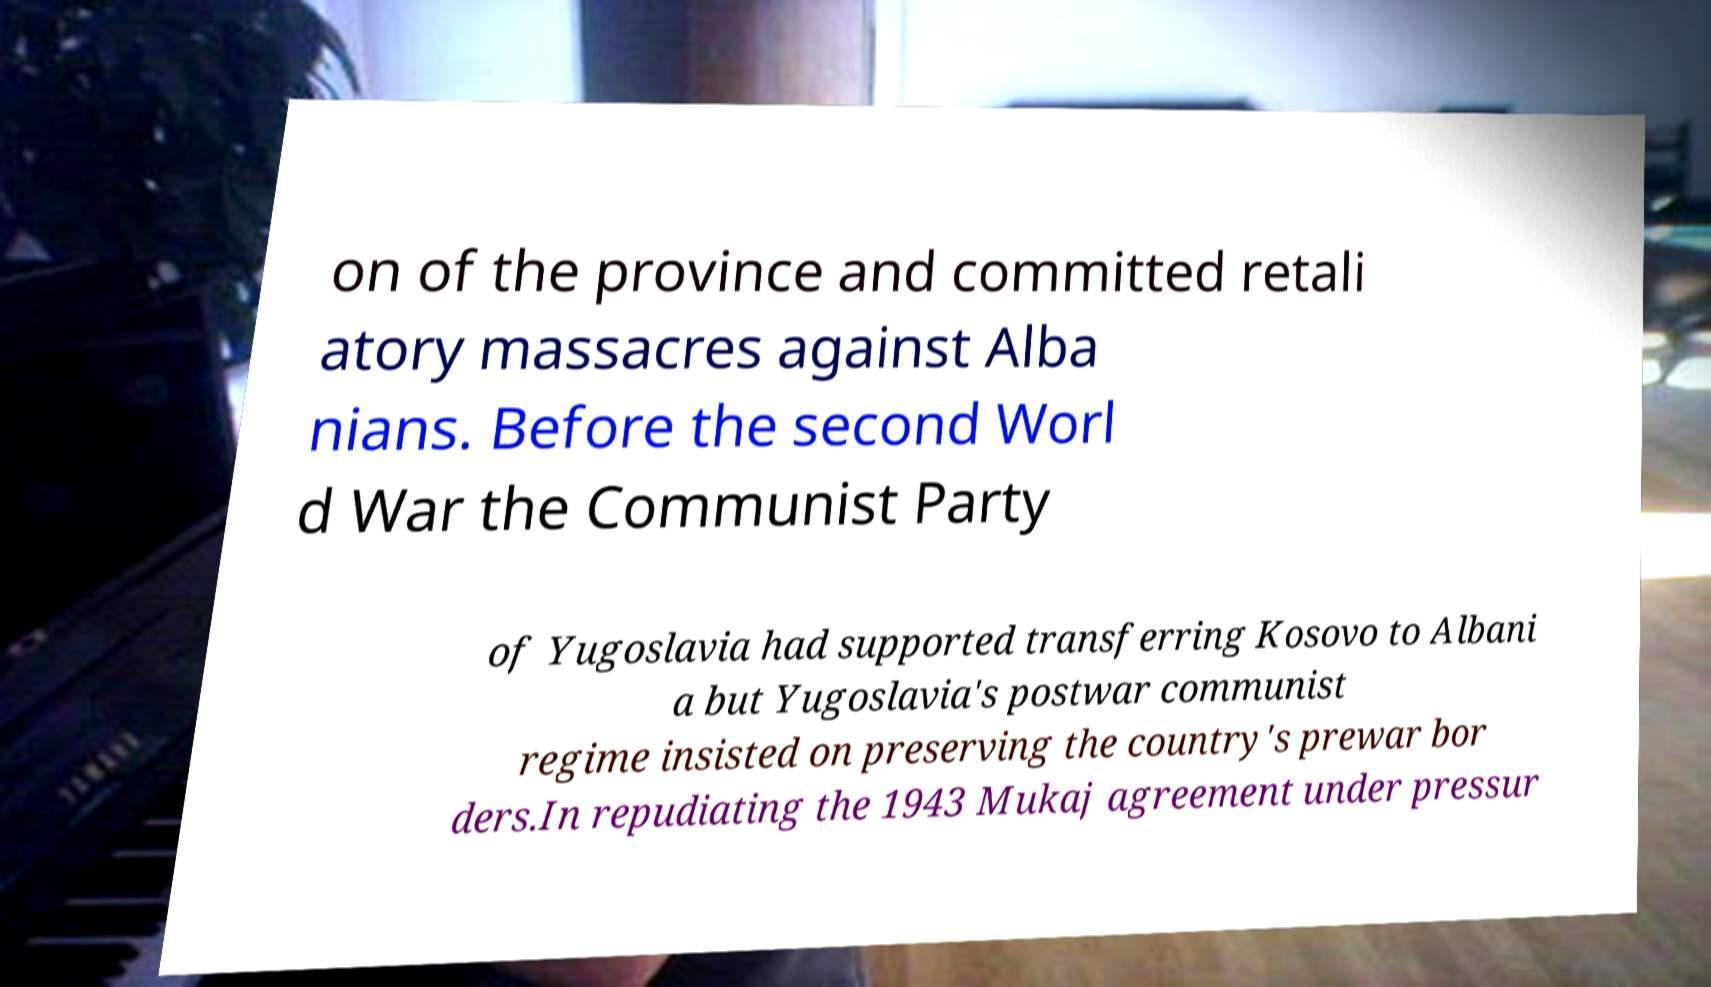I need the written content from this picture converted into text. Can you do that? on of the province and committed retali atory massacres against Alba nians. Before the second Worl d War the Communist Party of Yugoslavia had supported transferring Kosovo to Albani a but Yugoslavia's postwar communist regime insisted on preserving the country's prewar bor ders.In repudiating the 1943 Mukaj agreement under pressur 